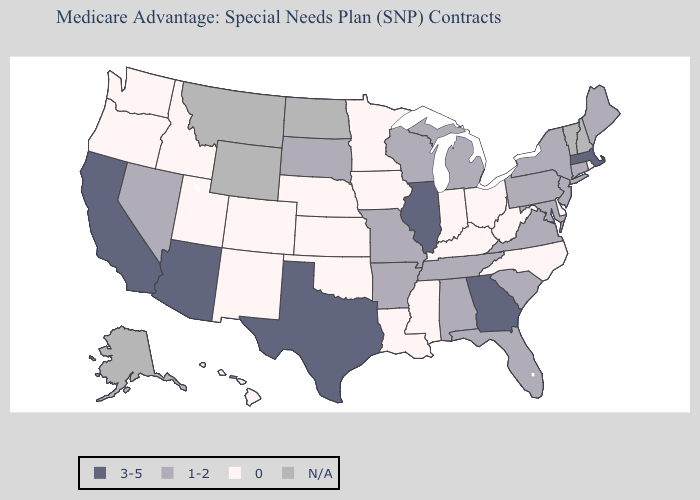Does Alabama have the lowest value in the USA?
Short answer required. No. Does Utah have the lowest value in the West?
Give a very brief answer. Yes. What is the highest value in the South ?
Quick response, please. 3-5. What is the value of New York?
Be succinct. 1-2. Name the states that have a value in the range 1-2?
Be succinct. Alabama, Arkansas, Connecticut, Florida, Maryland, Maine, Michigan, Missouri, New Jersey, Nevada, New York, Pennsylvania, South Carolina, South Dakota, Tennessee, Virginia, Wisconsin. Does the map have missing data?
Give a very brief answer. Yes. Among the states that border New Hampshire , does Maine have the lowest value?
Write a very short answer. Yes. Name the states that have a value in the range 0?
Write a very short answer. Colorado, Delaware, Hawaii, Iowa, Idaho, Indiana, Kansas, Kentucky, Louisiana, Minnesota, Mississippi, North Carolina, Nebraska, New Mexico, Ohio, Oklahoma, Oregon, Rhode Island, Utah, Washington, West Virginia. How many symbols are there in the legend?
Short answer required. 4. How many symbols are there in the legend?
Write a very short answer. 4. Name the states that have a value in the range 3-5?
Answer briefly. Arizona, California, Georgia, Illinois, Massachusetts, Texas. What is the lowest value in the USA?
Be succinct. 0. Among the states that border Vermont , which have the lowest value?
Write a very short answer. New York. 